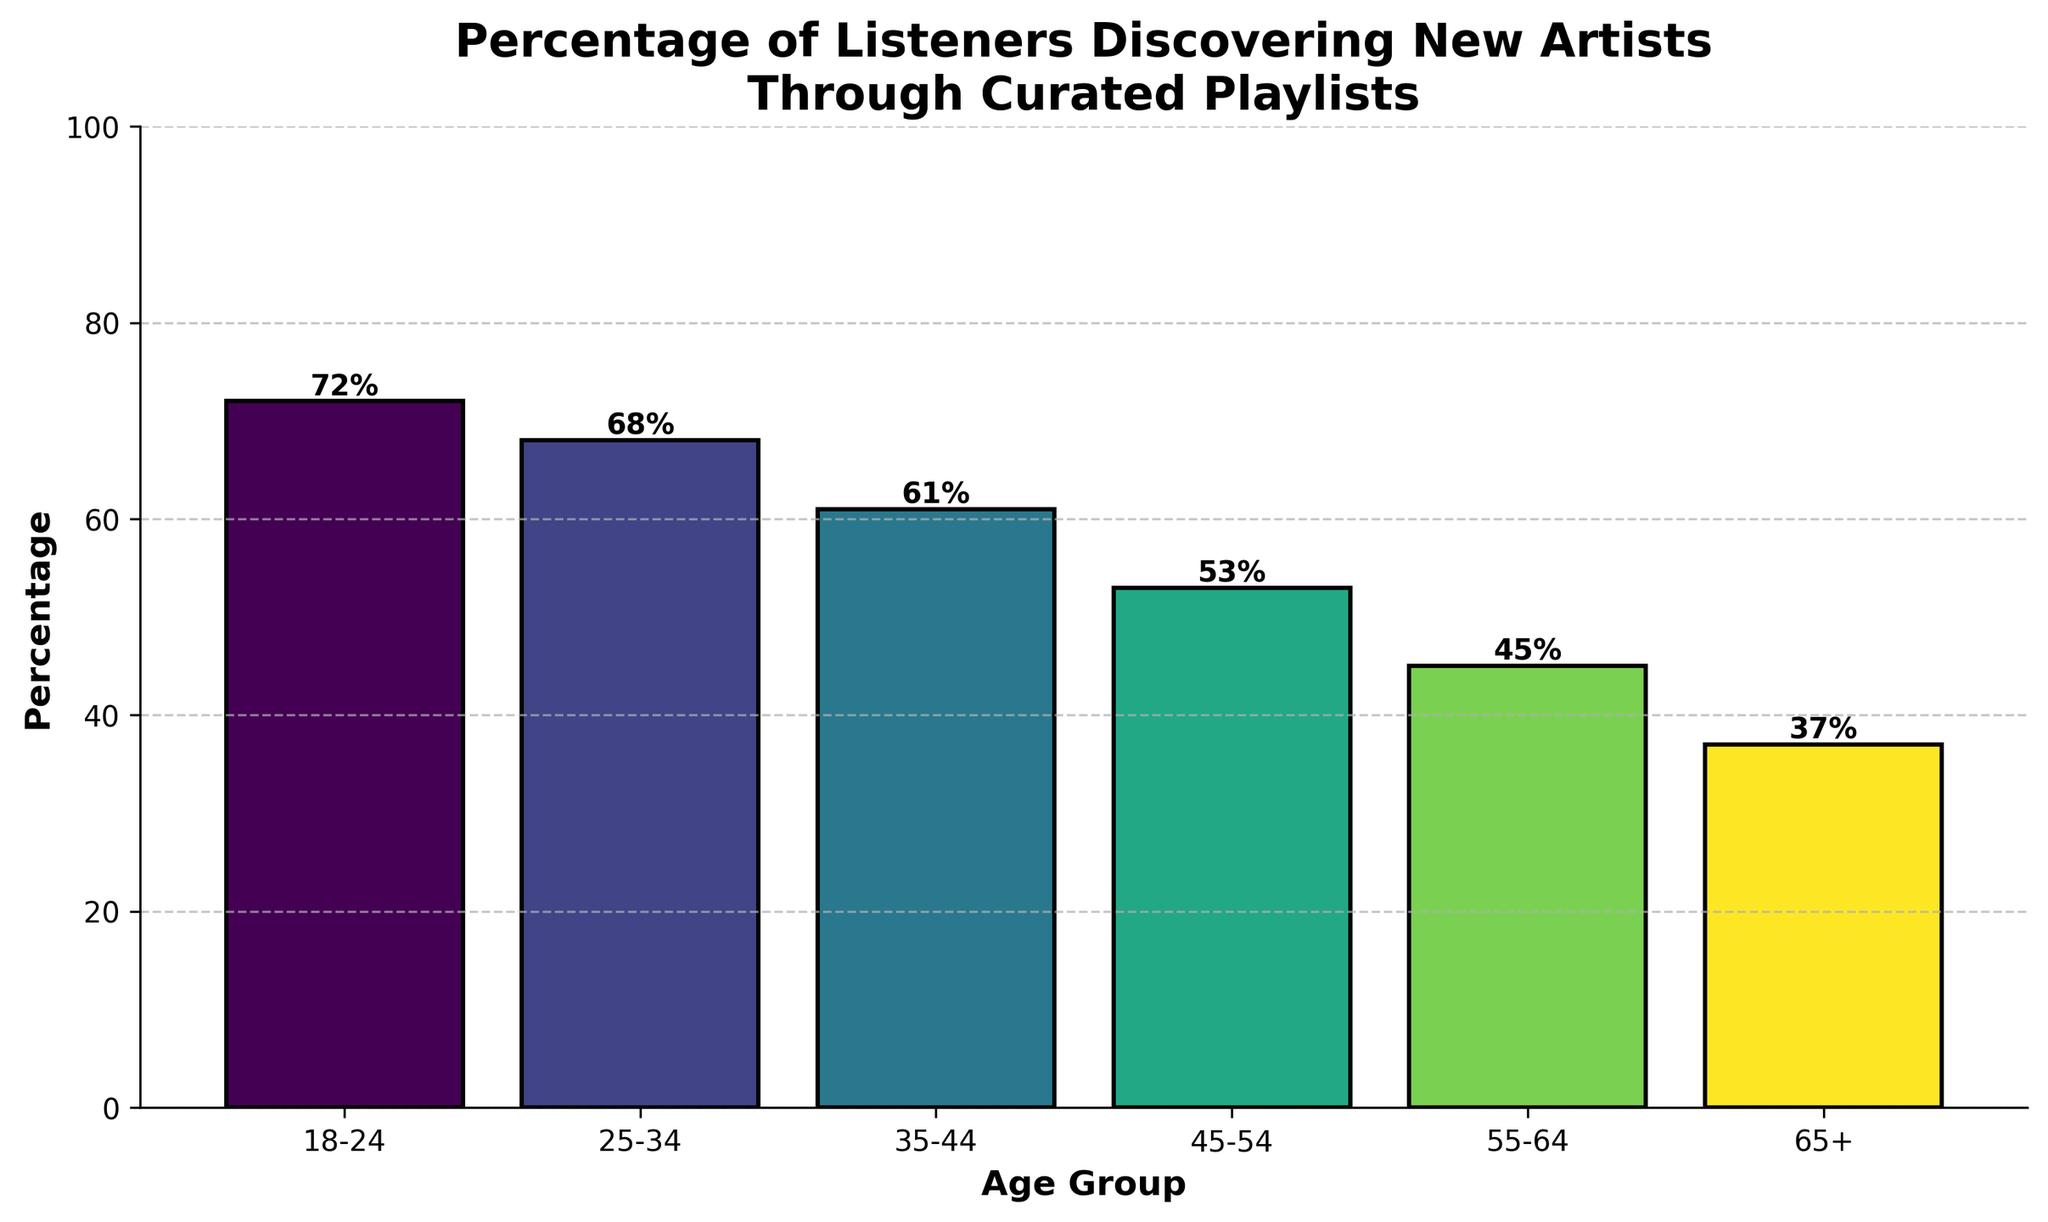What age group has the highest percentage of listeners discovering new artists through curated playlists? We observe the bar heights and their labels. The tallest bar corresponds to the 18-24 age group with a height of 72%.
Answer: 18-24 What's the difference in percentage between the youngest and oldest age groups? The youngest age group is 18-24 with 72%, and the oldest is 65+ with 37%. Subtract 37 from 72 to find the difference: 72 - 37 = 35%.
Answer: 35% Which age group has a percentage closest to 50%? By examining the bars, the 45-54 age group has a percentage of 53%, which is closest to 50%.
Answer: 45-54 What is the average percentage of listeners discovering new artists for age groups 35-44, 45-54, and 55-64? Sum the percentages of the given age groups: 61% + 53% + 45% = 159%. There are 3 age groups, so the average is 159 / 3 = 53%.
Answer: 53% How many age groups have a percentage greater than 60%? Identify bars above the 60% line. The bars for age groups 18-24, 25-34, and 35-44 are above 60%. This gives us 3 age groups.
Answer: 3 Which age group has the lowest percentage of listeners discovering new artists through curated playlists? Find the shortest bar in the chart. The smallest bar belongs to the 65+ age group with 37%.
Answer: 65+ What's the total percentage of all age groups combined? Sum all percentages: 72 + 68 + 61 + 53 + 45 + 37 = 336%.
Answer: 336% By how much does the percentage of the 45-54 age group exceed the percentage of the 55-64 age group? Subtract the percentage of the 55-64 age group (45%) from the 45-54 age group (53%): 53 - 45 = 8%.
Answer: 8% Is the percentage of the 25-34 age group greater than, less than, or equal to the average percentage of all age groups? First, find the average of all age groups by summing the percentages and dividing by 6: (72 + 68 + 61 + 53 + 45 + 37) / 6 = 56%. The 25-34 age group has 68%, which is greater than 56%.
Answer: Greater than 